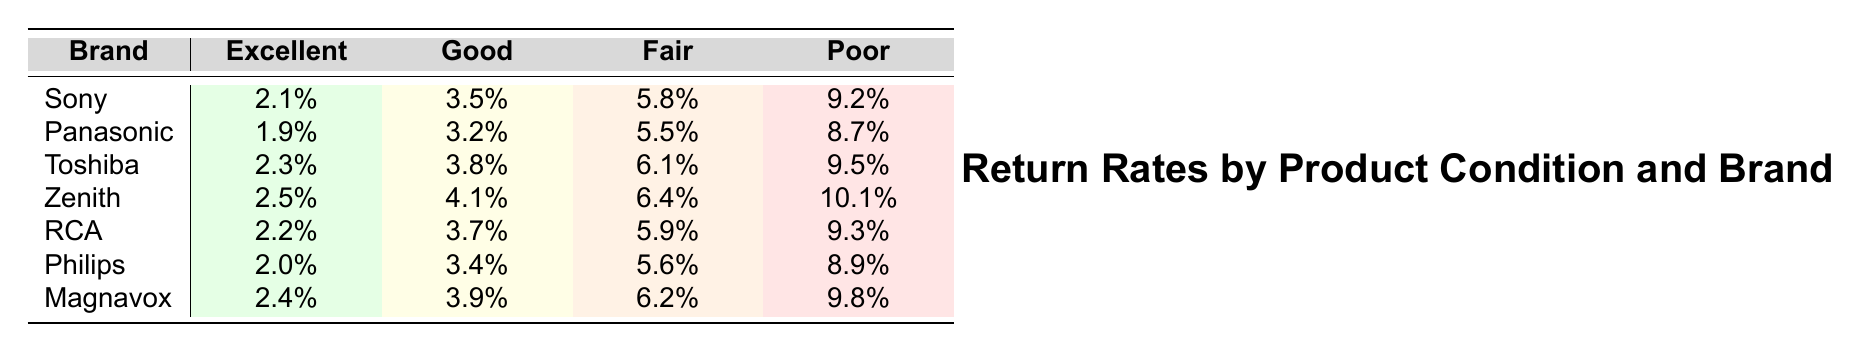What is the return rate for Sony products in excellent condition? The table shows that the return rate for Sony products in excellent condition is listed as 2.1%.
Answer: 2.1% Which brand has the highest return rate for products in poor condition? By examining the table, Zenith has the highest return rate at 10.1% for products in poor condition.
Answer: Zenith What is the return rate for Panasonic products in fair condition? The table states that the return rate for Panasonic products in fair condition is 5.5%.
Answer: 5.5% What is the difference in return rates between excellent and poor conditions for RCA? For RCA, the return rate is 2.2% in excellent condition and 9.3% in poor condition. The difference is 9.3% - 2.2% = 7.1%.
Answer: 7.1% Which brand's products have the lowest return rate in good condition? The table indicates that Panasonic has the lowest return rate at 3.2% in good condition.
Answer: Panasonic What is the average return rate for all brands in fair condition? The return rates for fair condition are 5.8%, 5.5%, 6.1%, 6.4%, 5.9%, 5.6%, and 6.2%. Summing these gives 41.5%, and dividing by 7 yields an average of 5.93%.
Answer: 5.93% Is the return rate for Toshiba products in good condition higher than that for Philips? The table shows Toshiba's return rate in good condition is 3.8% and Philips' is 3.4%. Since 3.8% > 3.4%, the statement is true.
Answer: Yes Which brand has consistently lower return rates across all conditions compared to others? Comparing all brands, Panasonic has the lowest rates of 1.9%, 3.2%, 5.5%, and 8.7%, which are lower than the other brands in all conditions.
Answer: Panasonic If we combine the return rates for excellent and good conditions for each brand, which brand has the highest combined rate? The combined return rates for excellent and good conditions for each brand are: Sony (5.6%), Panasonic (5.1%), Toshiba (6.1%), Zenith (6.6%), RCA (5.9%), Philips (5.4%), and Magnavox (6.3%). Zenith has the highest combined rate at 6.6%.
Answer: Zenith What is the return rate for products in fair condition across all brands? This would require checking the return rates for fair condition: 5.8%, 5.5%, 6.1%, 6.4%, 5.9%, 5.6%, and 6.2%. The one product with the highest return rate is from Zenith at 6.4%.
Answer: 6.4% 